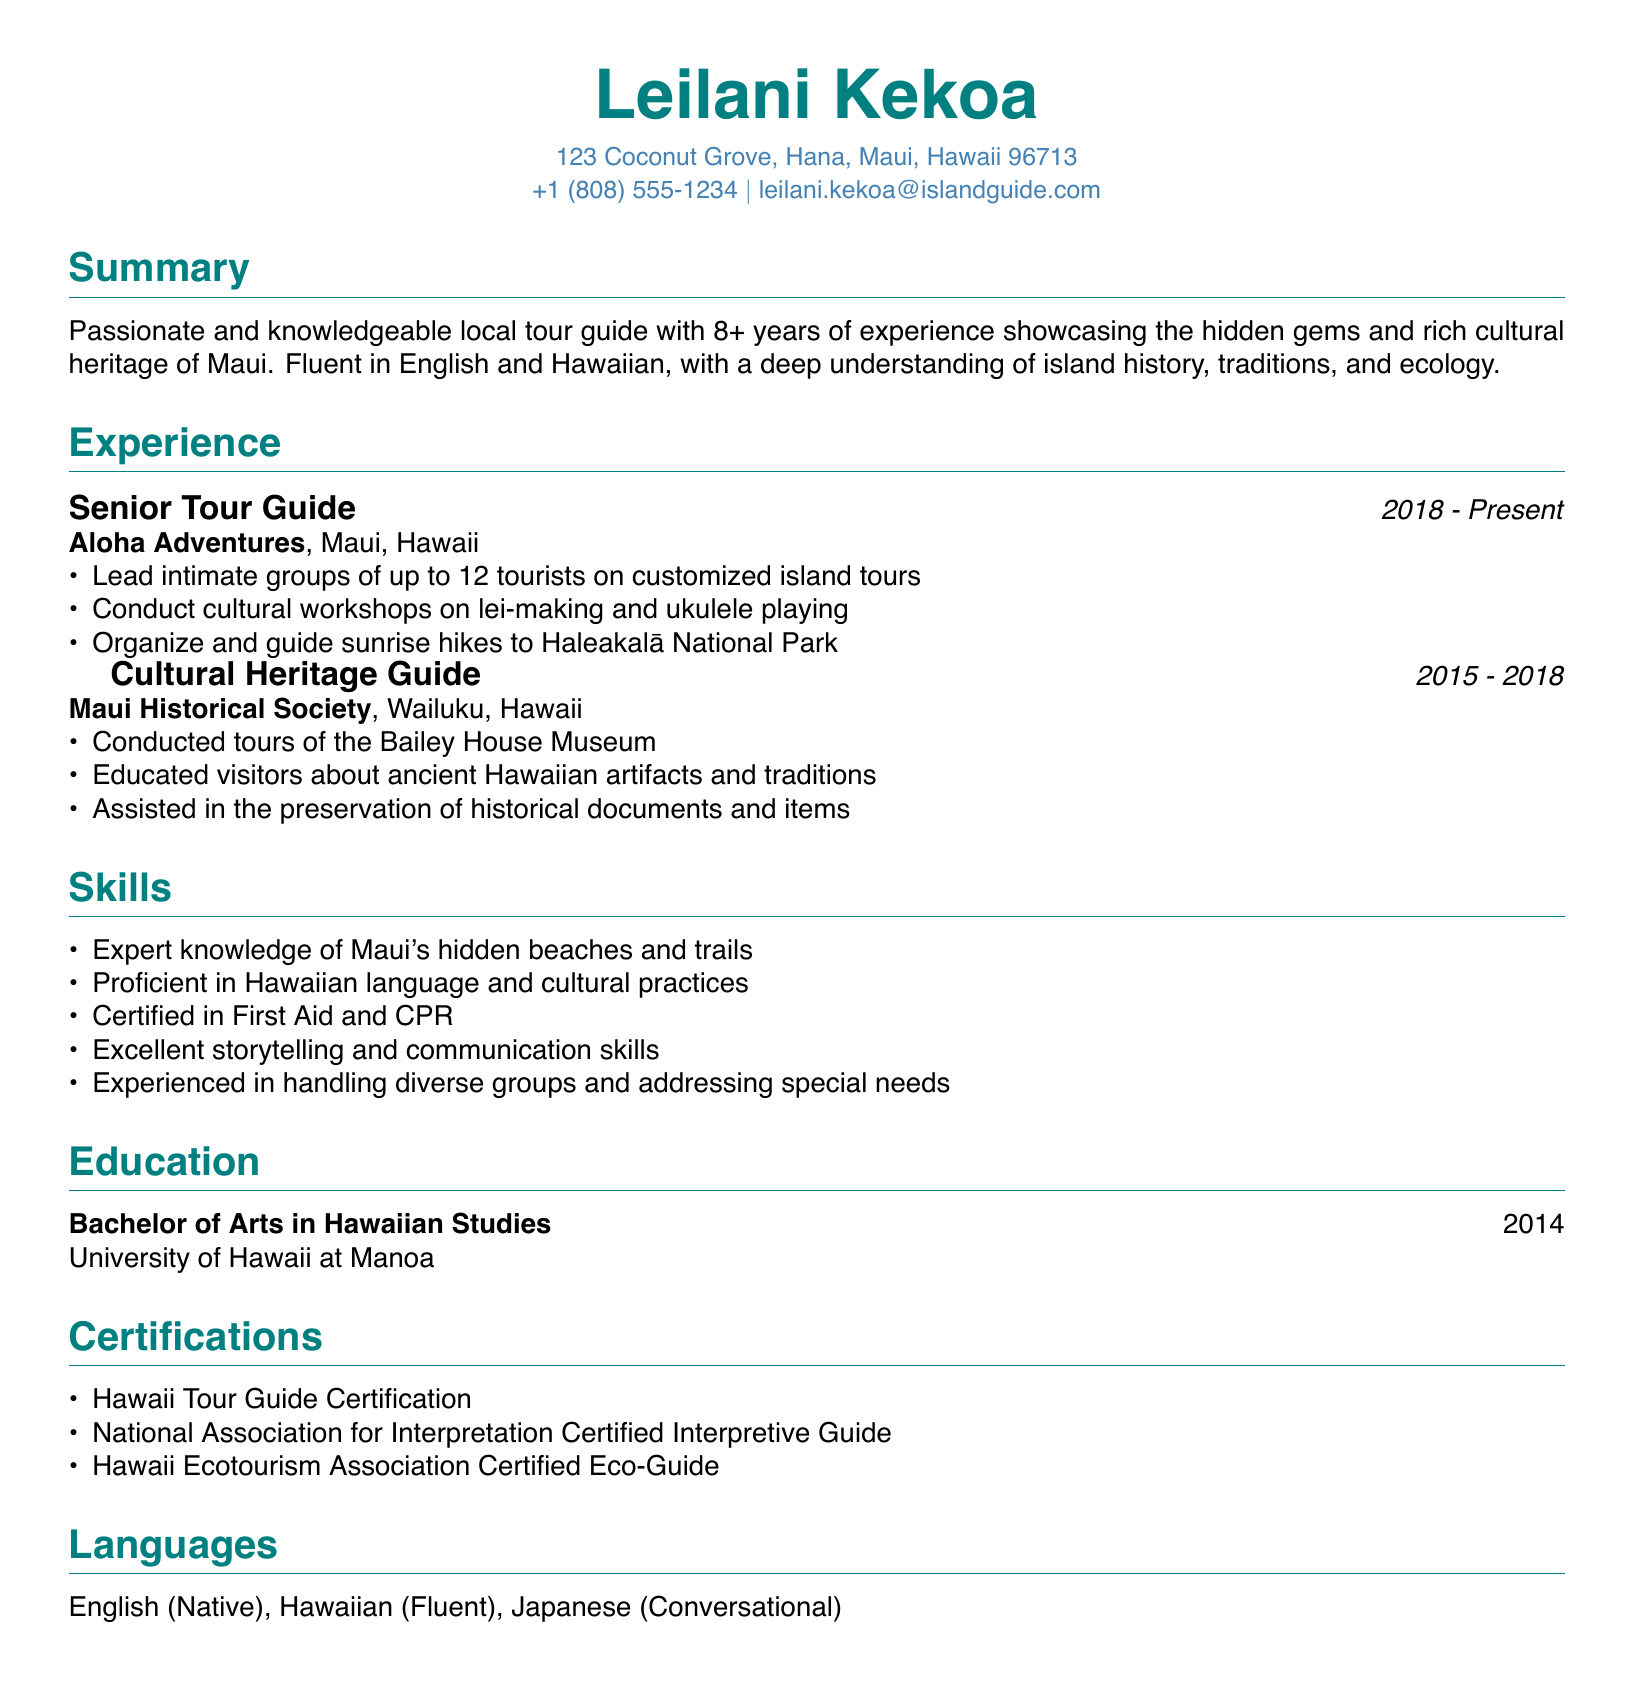What is the name of the local tour guide? The name is prominently displayed at the top of the document.
Answer: Leilani Kekoa What is Leilani’s current job title? The current job title is listed in the experience section of the CV.
Answer: Senior Tour Guide In which year did Leilani graduate from university? The graduation year is specified in the education section.
Answer: 2014 What languages is Leilani fluent in? The languages spoken fluently are listed in the languages section.
Answer: English, Hawaiian How many years of experience does Leilani have as a tour guide? The number of years is mentioned in the summary section.
Answer: 8+ Which company does Leilani work for currently? The name of the company is listed under her current job title.
Answer: Aloha Adventures What type of certification does Leilani have relating to tour guiding? The certifications listed demonstrate specific qualifications for tour guiding.
Answer: Hawaii Tour Guide Certification What unique skill does Leilani possess related to cultural practices? One of the skills mentioned highlights her expertise in cultural practices.
Answer: Proficient in Hawaiian language and cultural practices Which historical site did Leilani guide tours at? The specific site where tours were conducted is mentioned in her past experience.
Answer: Bailey House Museum 